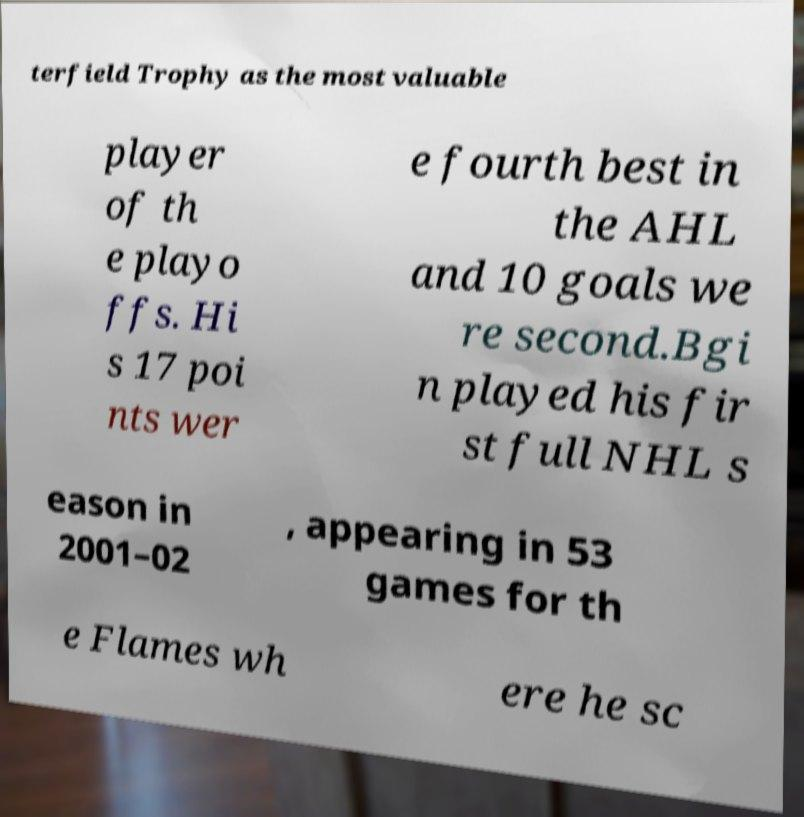Please read and relay the text visible in this image. What does it say? terfield Trophy as the most valuable player of th e playo ffs. Hi s 17 poi nts wer e fourth best in the AHL and 10 goals we re second.Bgi n played his fir st full NHL s eason in 2001–02 , appearing in 53 games for th e Flames wh ere he sc 